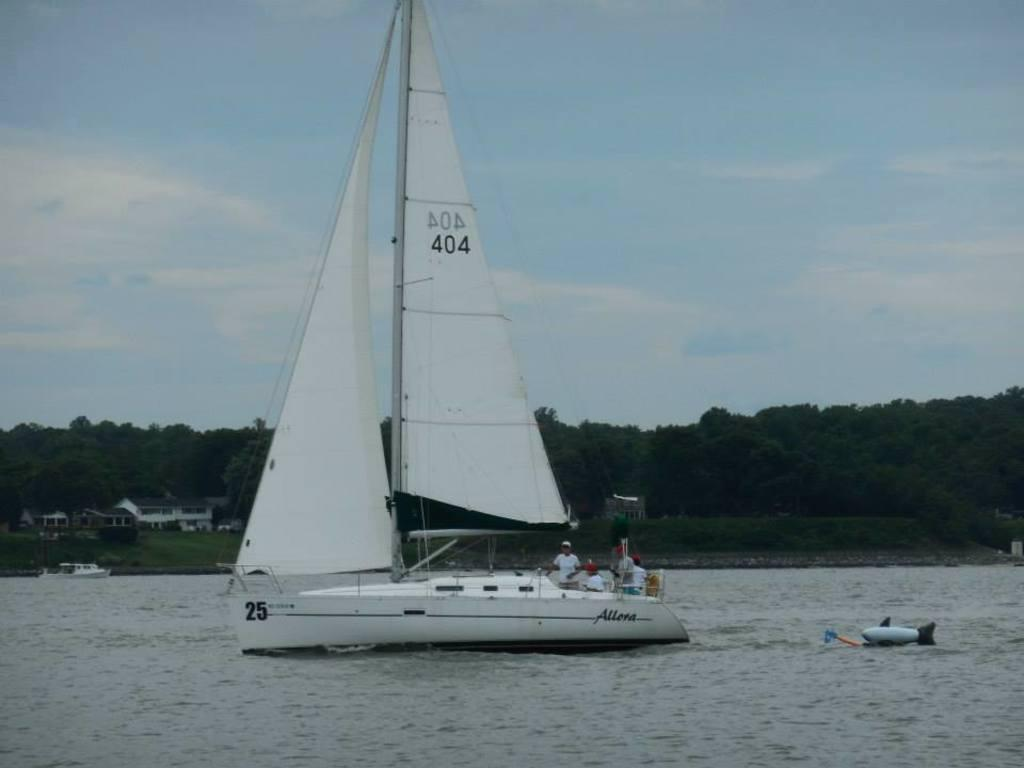What is on the water in the image? There are boats on the water in the image. Who or what can be seen in the image? There are people visible in the image. What type of vegetation is present in the image? Grass is present in the image. What type of structures can be seen in the image? There are houses in the image. What other natural elements are visible in the image? Trees are visible in the image. What else can be found in the image besides the main subjects? There are objects in the image. What is visible in the background of the image? The sky is visible in the background of the image. What can be seen in the sky? Clouds are present in the sky. Where are the flowers located in the image? There are no flowers mentioned or visible in the image. What type of toothpaste is being used by the people in the image? There is no toothpaste present or mentioned in the image. 